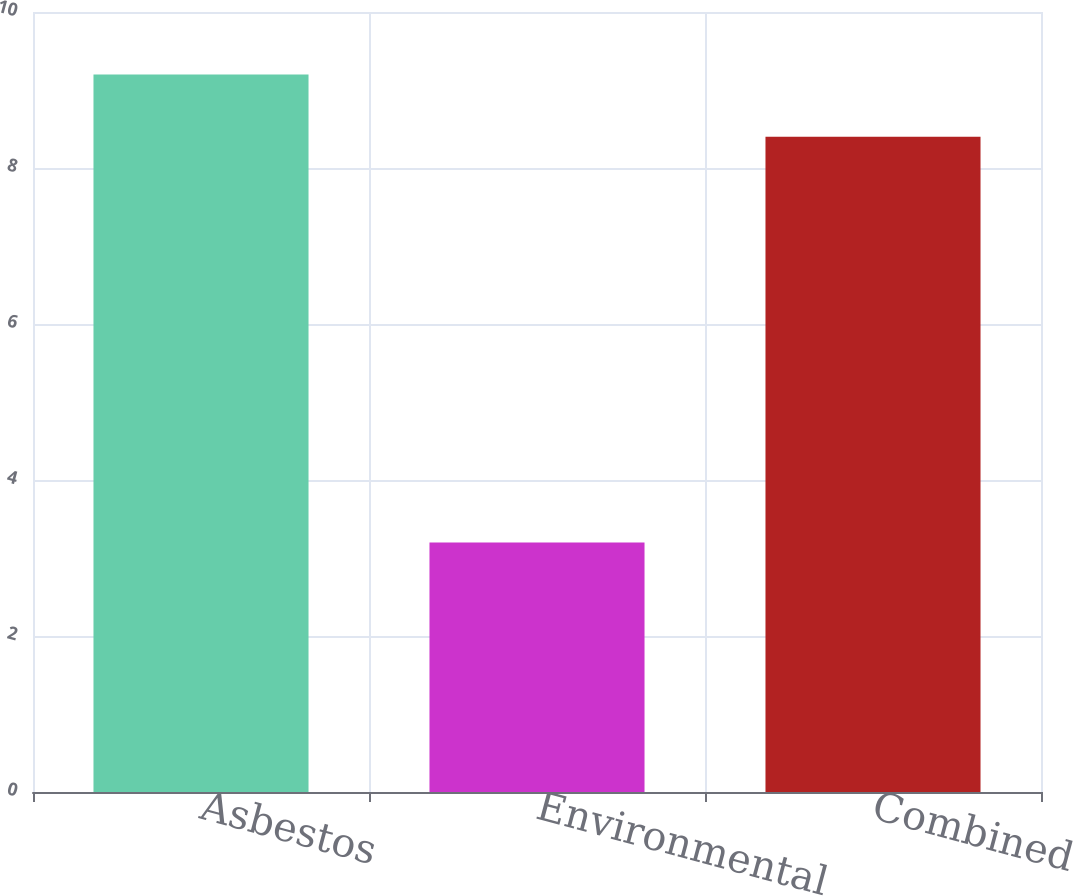Convert chart. <chart><loc_0><loc_0><loc_500><loc_500><bar_chart><fcel>Asbestos<fcel>Environmental<fcel>Combined<nl><fcel>9.2<fcel>3.2<fcel>8.4<nl></chart> 